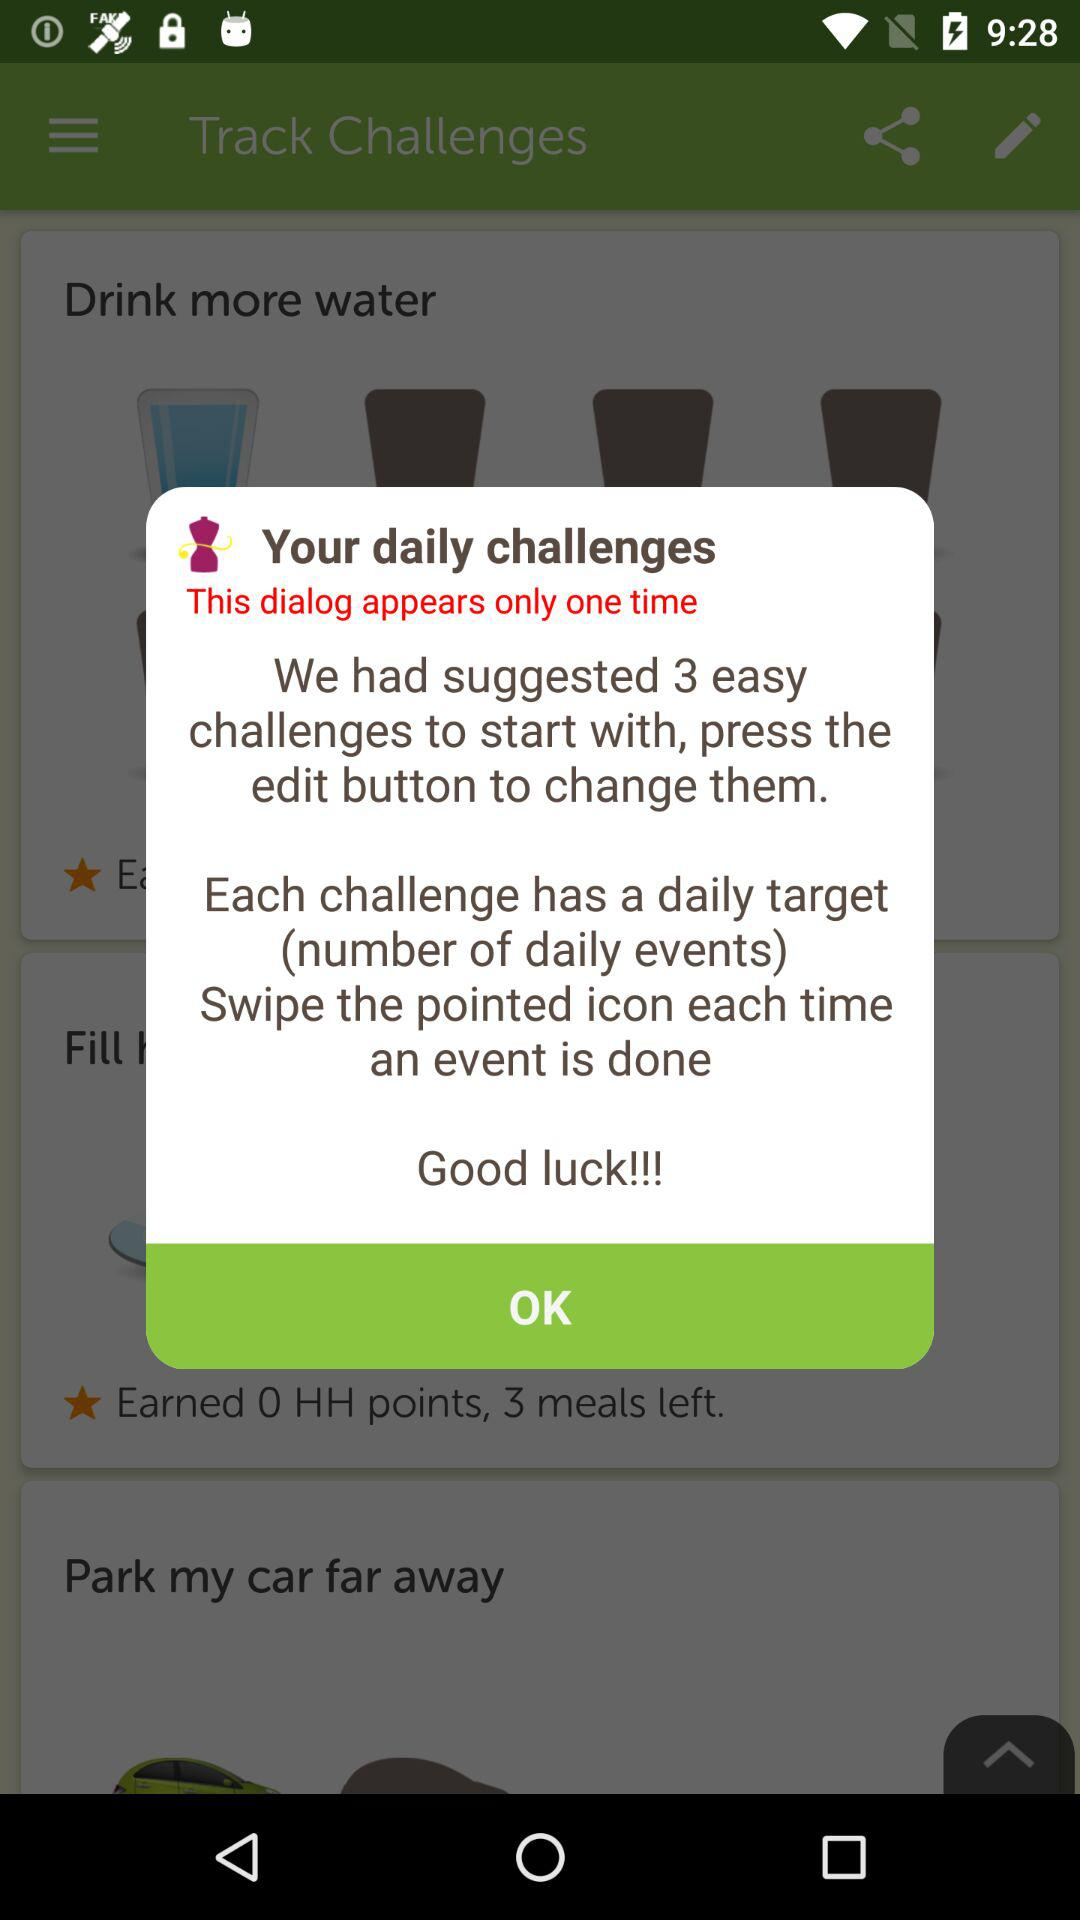How many challenges have we suggested? We have suggested three challenges. 